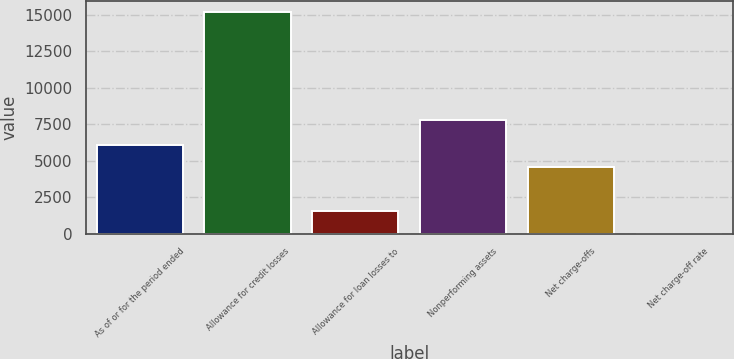Convert chart to OTSL. <chart><loc_0><loc_0><loc_500><loc_500><bar_chart><fcel>As of or for the period ended<fcel>Allowance for credit losses<fcel>Allowance for loan losses to<fcel>Nonperforming assets<fcel>Net charge-offs<fcel>Net charge-off rate<nl><fcel>6075.12<fcel>15187<fcel>1519.2<fcel>7757<fcel>4556.48<fcel>0.56<nl></chart> 